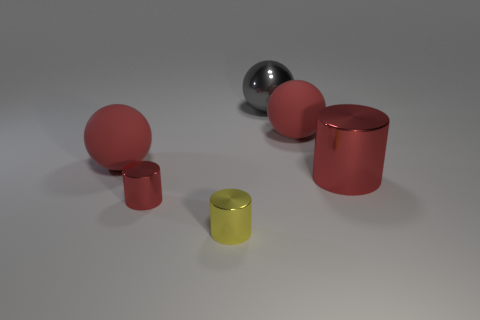Subtract all red cylinders. Subtract all purple cubes. How many cylinders are left? 1 Add 2 small yellow objects. How many objects exist? 8 Subtract all big red matte cylinders. Subtract all big red rubber objects. How many objects are left? 4 Add 2 large red balls. How many large red balls are left? 4 Add 4 big red things. How many big red things exist? 7 Subtract 0 cyan cylinders. How many objects are left? 6 